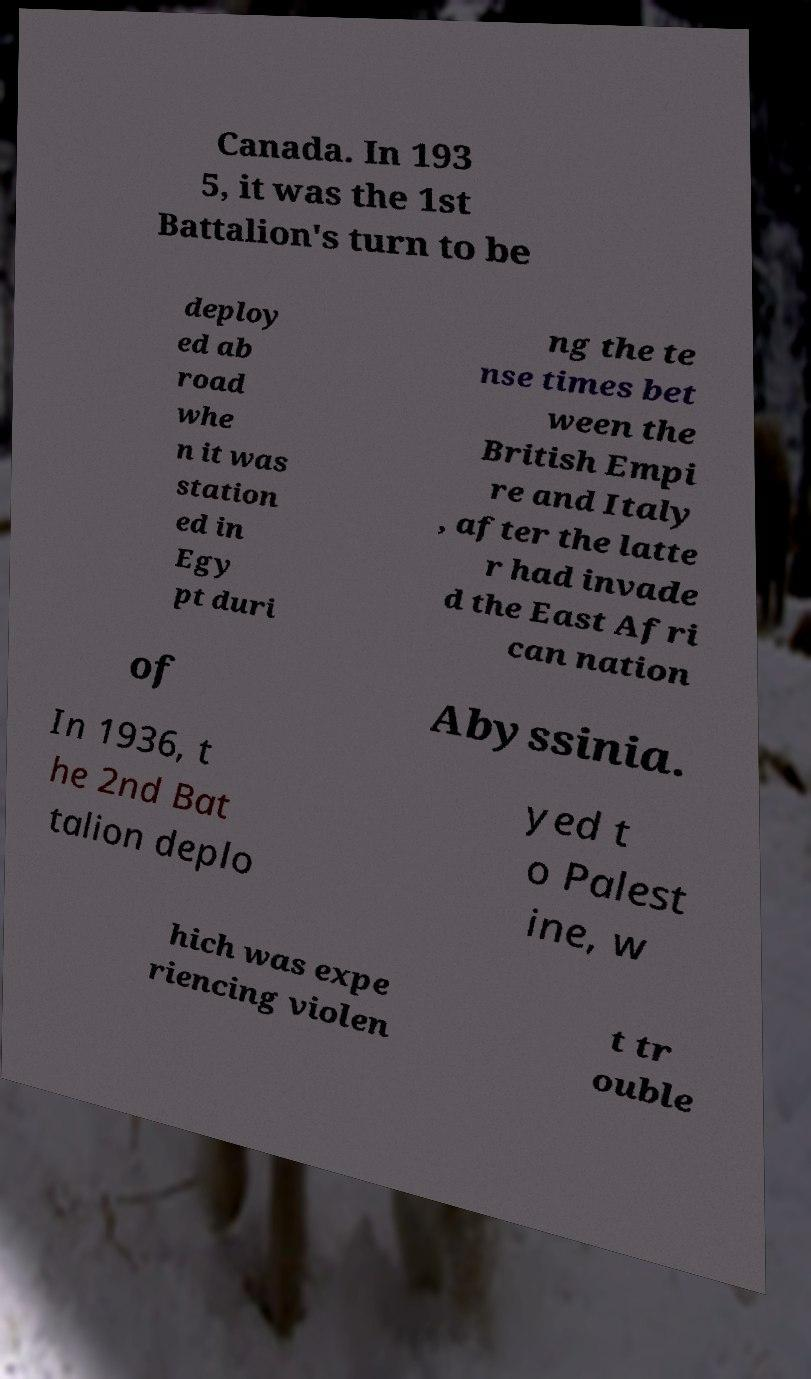There's text embedded in this image that I need extracted. Can you transcribe it verbatim? Canada. In 193 5, it was the 1st Battalion's turn to be deploy ed ab road whe n it was station ed in Egy pt duri ng the te nse times bet ween the British Empi re and Italy , after the latte r had invade d the East Afri can nation of Abyssinia. In 1936, t he 2nd Bat talion deplo yed t o Palest ine, w hich was expe riencing violen t tr ouble 